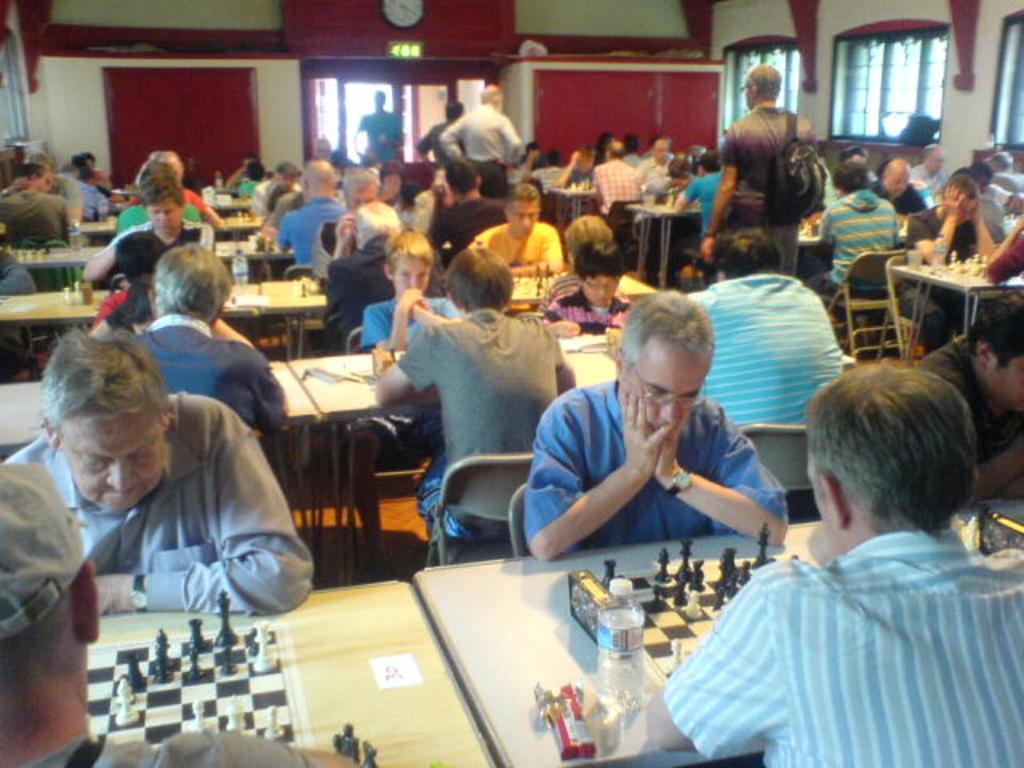How would you summarize this image in a sentence or two? As we can see in the image there is a white color wall, few people standing and sitting on chairs and there is a table. On table there are chess boards and coins and bottle. 